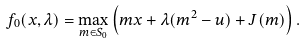Convert formula to latex. <formula><loc_0><loc_0><loc_500><loc_500>f _ { 0 } ( x , \lambda ) = \max _ { m \in S _ { 0 } } \left ( m x + \lambda ( m ^ { 2 } - u ) + J ( m ) \right ) .</formula> 